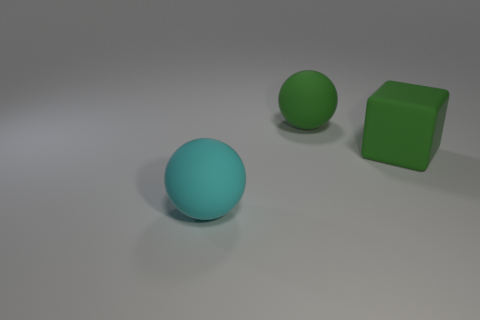Is there a cyan object made of the same material as the big block?
Offer a terse response. Yes. Are there the same number of objects behind the green block and green matte things that are on the left side of the cyan matte object?
Provide a succinct answer. No. There is a thing to the right of the large ball behind the green rubber cube; what is its material?
Offer a very short reply. Rubber. There is a rubber ball in front of the green object on the right side of the green ball; how many large cyan matte things are to the right of it?
Ensure brevity in your answer.  0. How many other big cyan matte objects are the same shape as the big cyan matte object?
Offer a terse response. 0. Are there more objects in front of the cube than big gray metal cylinders?
Your answer should be very brief. Yes. The large rubber thing behind the green thing that is on the right side of the ball that is behind the cyan ball is what shape?
Keep it short and to the point. Sphere. Does the green thing left of the green block have the same shape as the rubber thing that is to the right of the green sphere?
Your response must be concise. No. How many cubes are either large green objects or big cyan matte things?
Offer a very short reply. 1. Are the cube and the big cyan object made of the same material?
Provide a succinct answer. Yes. 